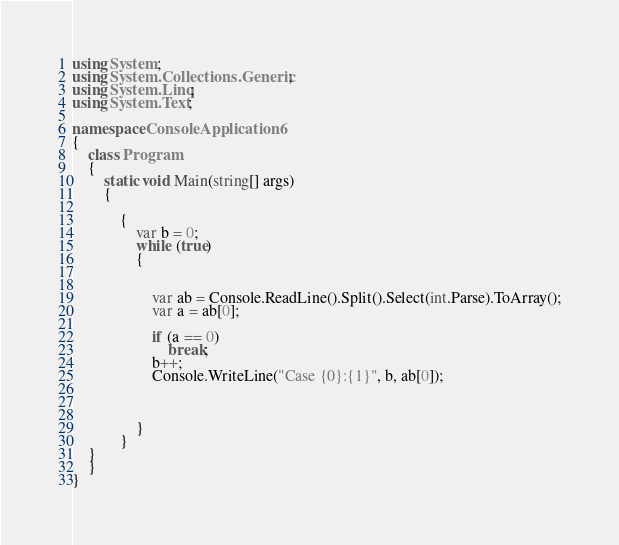<code> <loc_0><loc_0><loc_500><loc_500><_C#_>using System;
using System.Collections.Generic;
using System.Linq;
using System.Text;

namespace ConsoleApplication6
{
    class Program
    {
        static void Main(string[] args)
        {
            
            {
                var b = 0;
                while (true)
                {


                    var ab = Console.ReadLine().Split().Select(int.Parse).ToArray();
                    var a = ab[0];

                    if (a == 0)
                        break;
                    b++;
                    Console.WriteLine("Case {0}:{1}", b, ab[0]);



                }
            }
    }
    }
}</code> 